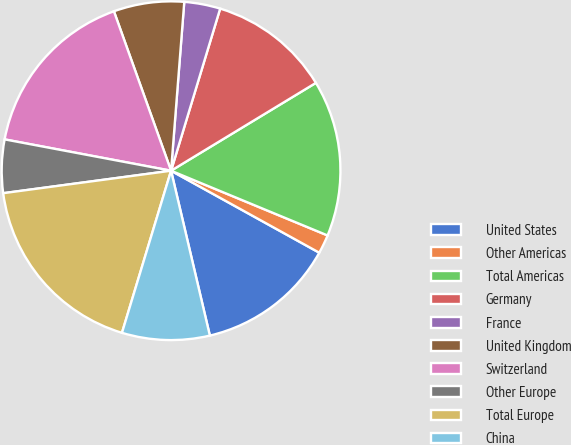Convert chart to OTSL. <chart><loc_0><loc_0><loc_500><loc_500><pie_chart><fcel>United States<fcel>Other Americas<fcel>Total Americas<fcel>Germany<fcel>France<fcel>United Kingdom<fcel>Switzerland<fcel>Other Europe<fcel>Total Europe<fcel>China<nl><fcel>13.28%<fcel>1.8%<fcel>14.92%<fcel>11.64%<fcel>3.44%<fcel>6.72%<fcel>16.56%<fcel>5.08%<fcel>18.2%<fcel>8.36%<nl></chart> 